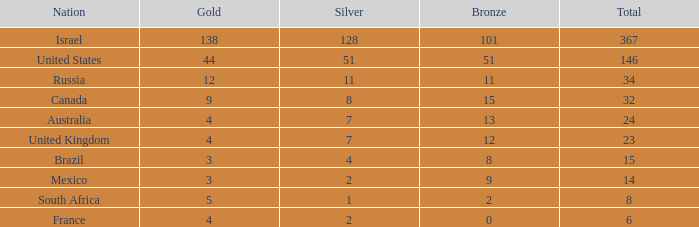What is the maximum number of silvers for a country with fewer than 12 golds and a total less than 8? 2.0. Could you parse the entire table as a dict? {'header': ['Nation', 'Gold', 'Silver', 'Bronze', 'Total'], 'rows': [['Israel', '138', '128', '101', '367'], ['United States', '44', '51', '51', '146'], ['Russia', '12', '11', '11', '34'], ['Canada', '9', '8', '15', '32'], ['Australia', '4', '7', '13', '24'], ['United Kingdom', '4', '7', '12', '23'], ['Brazil', '3', '4', '8', '15'], ['Mexico', '3', '2', '9', '14'], ['South Africa', '5', '1', '2', '8'], ['France', '4', '2', '0', '6']]} 